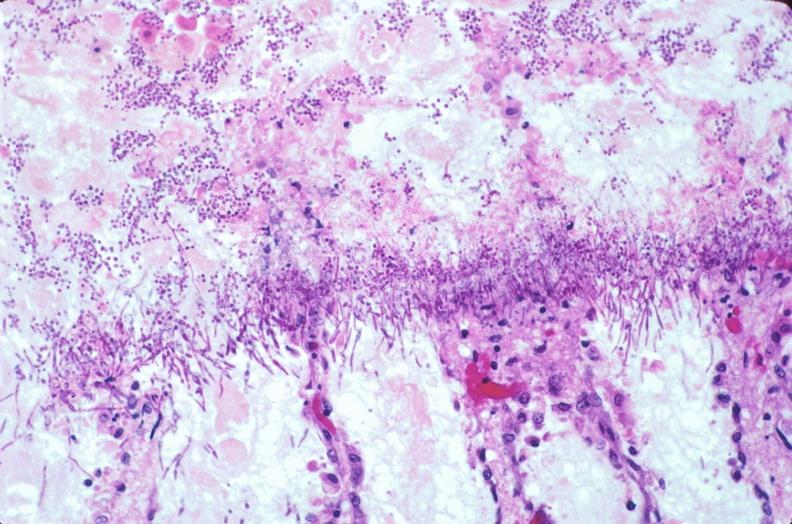what is present?
Answer the question using a single word or phrase. Gastrointestinal 